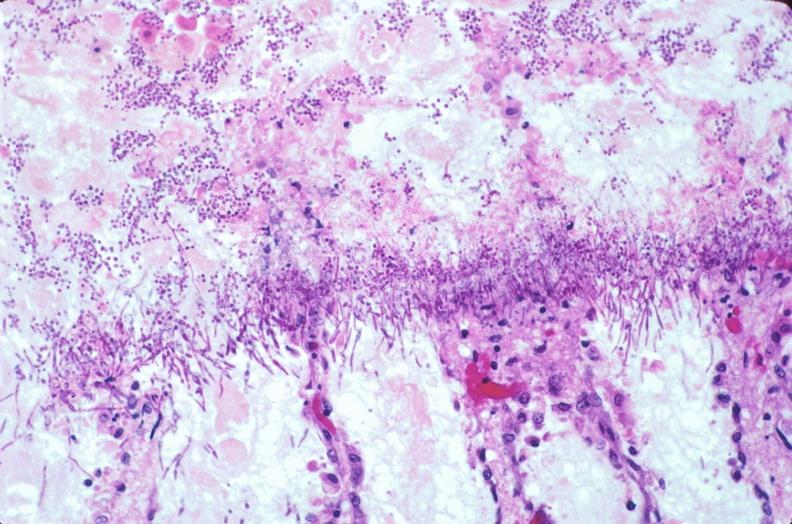what is present?
Answer the question using a single word or phrase. Gastrointestinal 